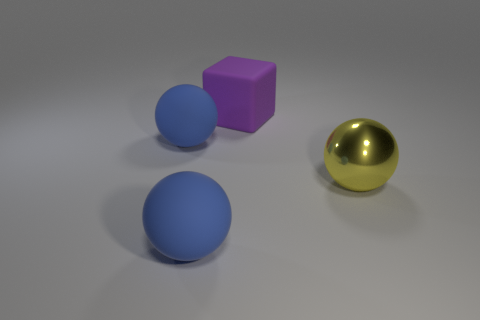What material is the big ball to the right of the big block? metal 